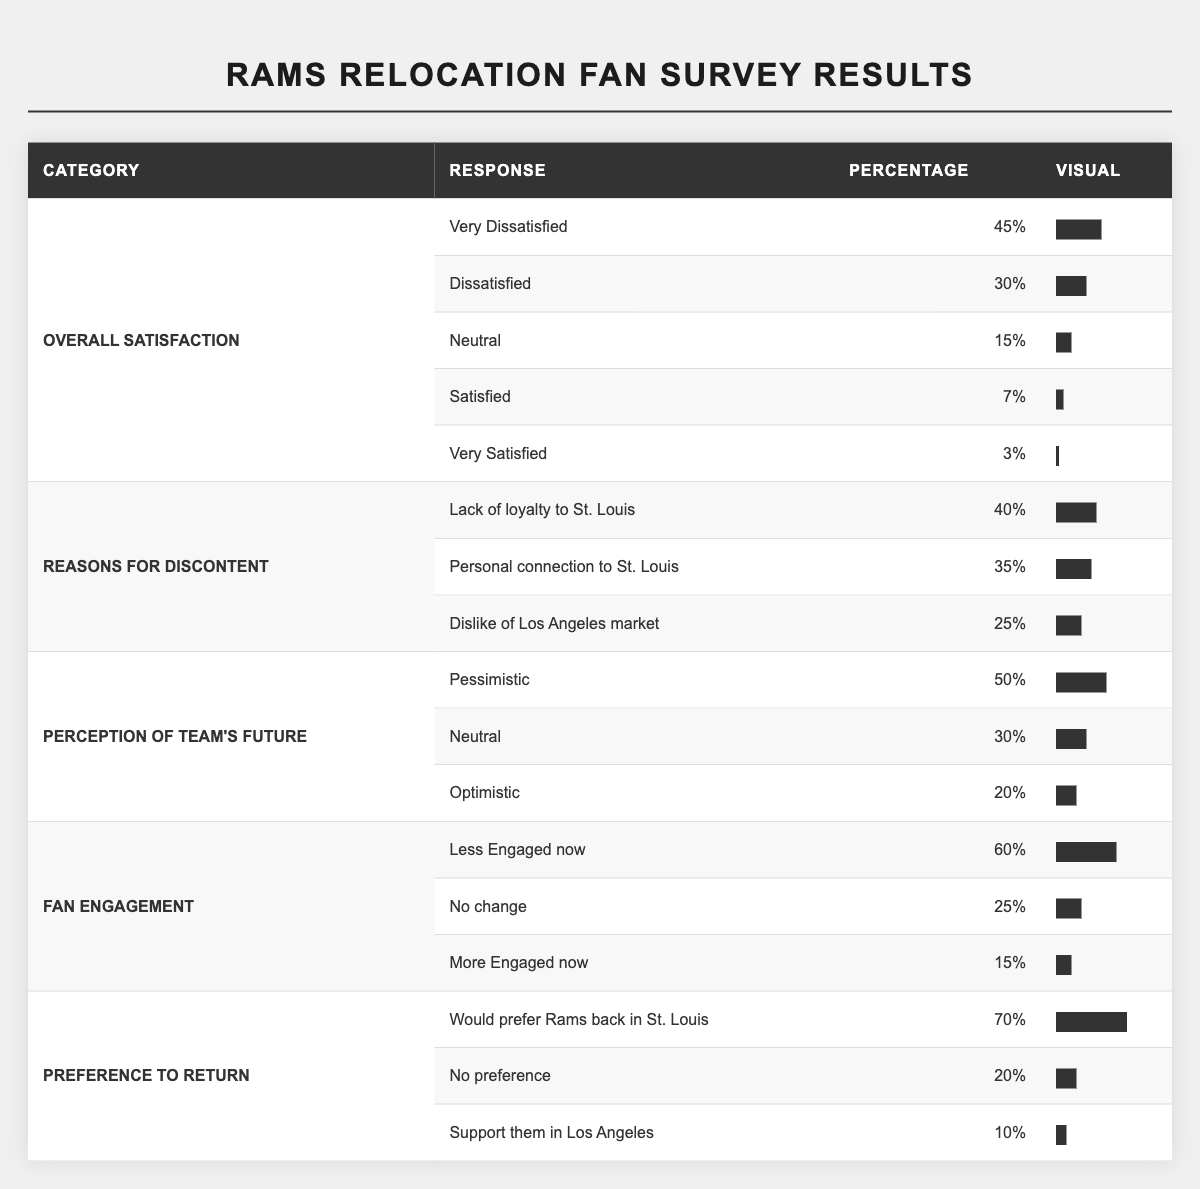What percentage of fans are very dissatisfied with the Rams' move? The table shows that 45% of fans responded with "Very Dissatisfied" regarding their overall satisfaction with the Rams' move.
Answer: 45% What is the combined percentage of fans who are dissatisfied or very dissatisfied? To find this, add the percentages of "Very Dissatisfied" (45%) and "Dissatisfied" (30%): 45% + 30% = 75%.
Answer: 75% Are more fans pessimistic about the team's future than optimistic? According to the table, 50% of fans are pessimistic and 20% are optimistic. Since 50% is greater than 20%, the statement is true.
Answer: Yes What percentage of fans feel less engaged now compared to before the move? The table indicates that 60% of fans feel "Less Engaged now." This is the percentage of fans expressing reduced engagement.
Answer: 60% If 70% of fans would prefer the Rams back in St. Louis, what percentage do not have a preference or support them in Los Angeles? The total percentage of fans who do not want them back in St. Louis is the sum of "No preference" (20%) and "Support them in Los Angeles" (10%): 20% + 10% = 30%.
Answer: 30% What is the percentage difference between fans who are less engaged now and those who are more engaged now? The percentage of fans who are less engaged is 60% and those who are more engaged is 15%. The difference is calculated as 60% - 15% = 45%.
Answer: 45% Is there a significant number of fans who are optimistic about the team's future? Only 20% of fans responded with "Optimistic," which is a relatively low percentage compared to those who are pessimistic (50%). Thus, it indicates that optimism is not significant among the fans.
Answer: No How do the percentages of "Lack of loyalty to St. Louis" and "Dislike of Los Angeles market" compare? The percentage for "Lack of loyalty to St. Louis" is 40% and "Dislike of Los Angeles market" is 25%; 40% is greater than 25%. Therefore, more fans express discontent regarding loyalty than the dislike for the market.
Answer: More fans express discontent regarding loyalty What percentage of fans feel neutral about the Rams' move? The table shows that 15% of fans feel "Neutral" in the overall satisfaction category.
Answer: 15% If the total percentages for the "Reasons for Discontent" category is calculated, what should it equal? The total percentage should equal 100%. Calculating: 40% (Lack of loyalty) + 35% (Personal connection) + 25% (Dislike of market) = 100%.
Answer: 100% How does the percentage of fans who are neutral about the team's future compare to the percentage that feels pessimistic? The "Neutral" percentage is 30%, and the "Pessimistic" is 50%. Since 30% is less than 50%, fewer fans feel neutral compared to those who are pessimistic.
Answer: Fewer fans feel neutral 